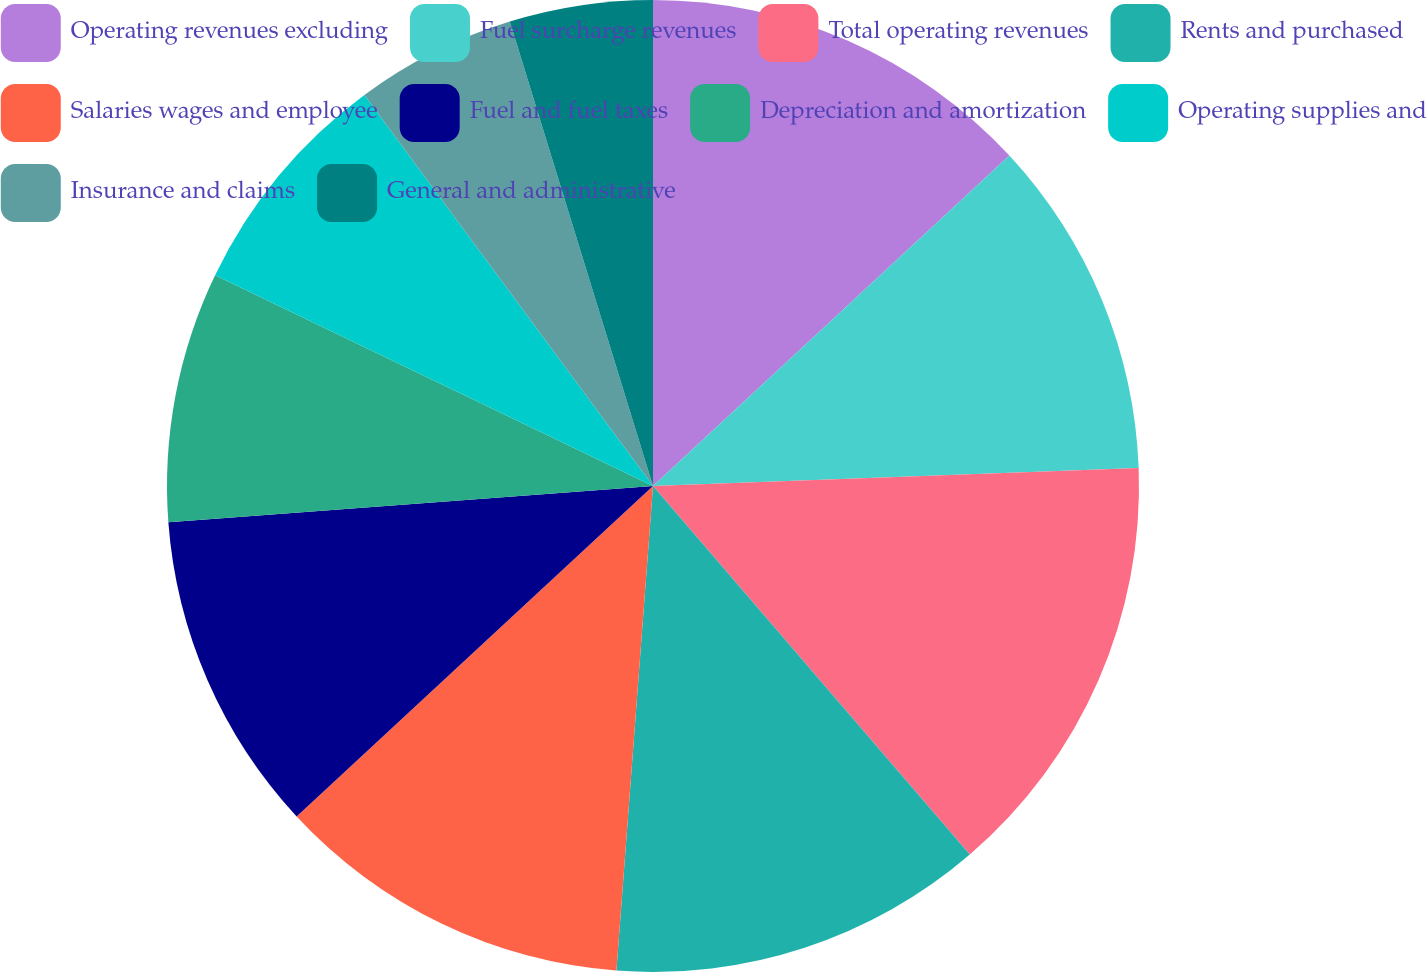Convert chart to OTSL. <chart><loc_0><loc_0><loc_500><loc_500><pie_chart><fcel>Operating revenues excluding<fcel>Fuel surcharge revenues<fcel>Total operating revenues<fcel>Rents and purchased<fcel>Salaries wages and employee<fcel>Fuel and fuel taxes<fcel>Depreciation and amortization<fcel>Operating supplies and<fcel>Insurance and claims<fcel>General and administrative<nl><fcel>13.1%<fcel>11.31%<fcel>14.29%<fcel>12.5%<fcel>11.9%<fcel>10.71%<fcel>8.33%<fcel>7.74%<fcel>5.36%<fcel>4.76%<nl></chart> 